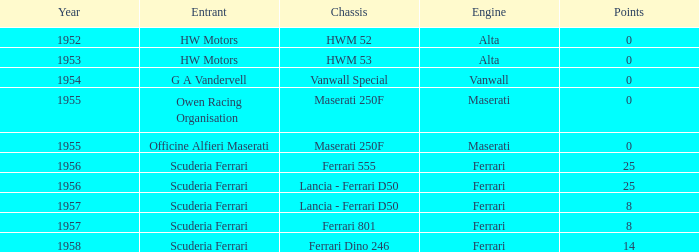What is the entrant earlier than 1956 with a Vanwall Special chassis? G A Vandervell. Help me parse the entirety of this table. {'header': ['Year', 'Entrant', 'Chassis', 'Engine', 'Points'], 'rows': [['1952', 'HW Motors', 'HWM 52', 'Alta', '0'], ['1953', 'HW Motors', 'HWM 53', 'Alta', '0'], ['1954', 'G A Vandervell', 'Vanwall Special', 'Vanwall', '0'], ['1955', 'Owen Racing Organisation', 'Maserati 250F', 'Maserati', '0'], ['1955', 'Officine Alfieri Maserati', 'Maserati 250F', 'Maserati', '0'], ['1956', 'Scuderia Ferrari', 'Ferrari 555', 'Ferrari', '25'], ['1956', 'Scuderia Ferrari', 'Lancia - Ferrari D50', 'Ferrari', '25'], ['1957', 'Scuderia Ferrari', 'Lancia - Ferrari D50', 'Ferrari', '8'], ['1957', 'Scuderia Ferrari', 'Ferrari 801', 'Ferrari', '8'], ['1958', 'Scuderia Ferrari', 'Ferrari Dino 246', 'Ferrari', '14']]} 